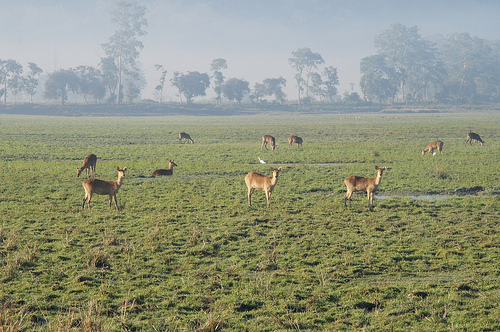<image>
Is there a goat on the grass? Yes. Looking at the image, I can see the goat is positioned on top of the grass, with the grass providing support. Where is the doe in relation to the trees? Is it in front of the trees? Yes. The doe is positioned in front of the trees, appearing closer to the camera viewpoint. 